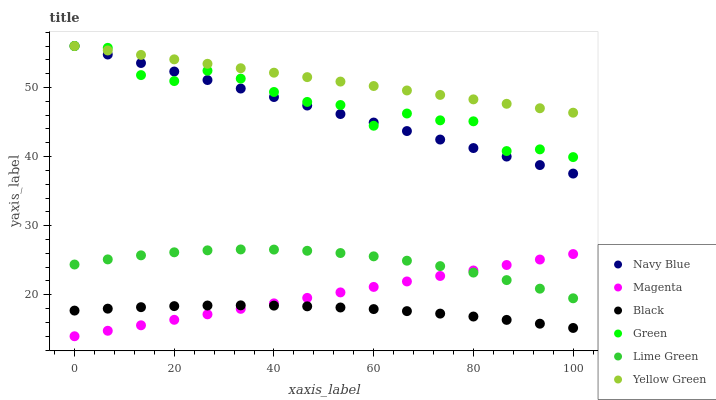Does Black have the minimum area under the curve?
Answer yes or no. Yes. Does Yellow Green have the maximum area under the curve?
Answer yes or no. Yes. Does Navy Blue have the minimum area under the curve?
Answer yes or no. No. Does Navy Blue have the maximum area under the curve?
Answer yes or no. No. Is Magenta the smoothest?
Answer yes or no. Yes. Is Green the roughest?
Answer yes or no. Yes. Is Navy Blue the smoothest?
Answer yes or no. No. Is Navy Blue the roughest?
Answer yes or no. No. Does Magenta have the lowest value?
Answer yes or no. Yes. Does Navy Blue have the lowest value?
Answer yes or no. No. Does Green have the highest value?
Answer yes or no. Yes. Does Black have the highest value?
Answer yes or no. No. Is Lime Green less than Navy Blue?
Answer yes or no. Yes. Is Lime Green greater than Black?
Answer yes or no. Yes. Does Navy Blue intersect Green?
Answer yes or no. Yes. Is Navy Blue less than Green?
Answer yes or no. No. Is Navy Blue greater than Green?
Answer yes or no. No. Does Lime Green intersect Navy Blue?
Answer yes or no. No. 